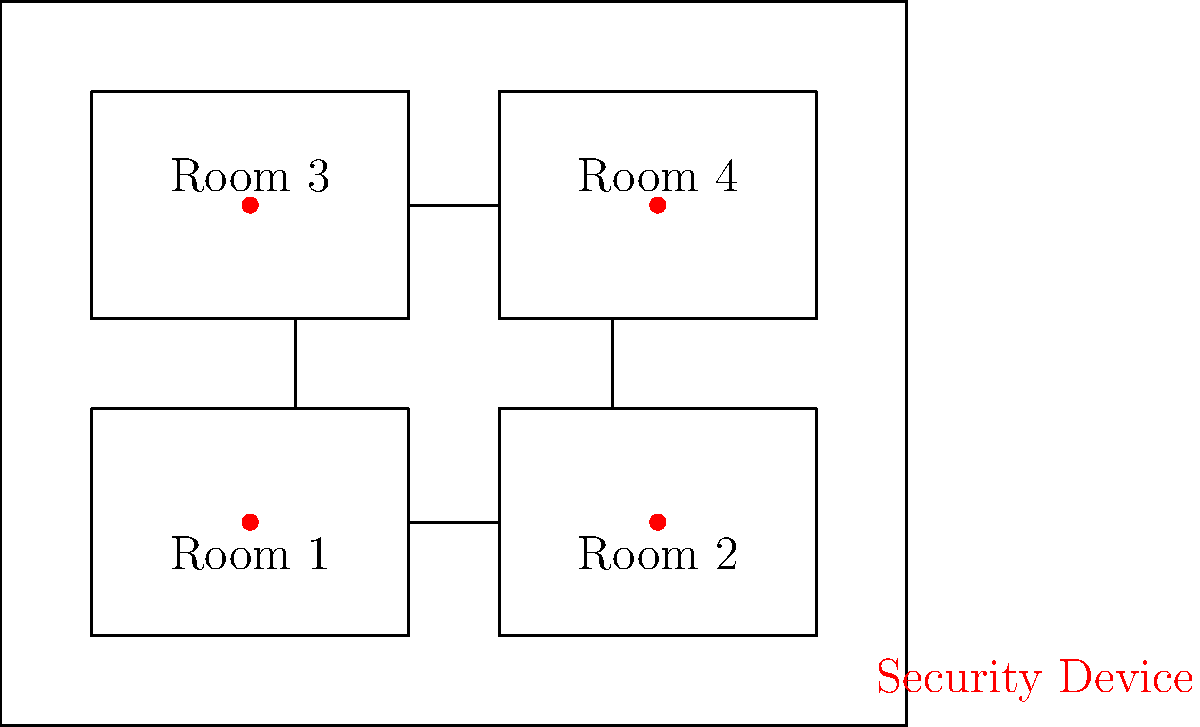Based on the floor plan shown, which integration strategy would be most effective for implementing a comprehensive campus security system that ensures seamless communication between devices and centralized control? To determine the most effective integration strategy for a comprehensive campus security system, we need to consider several factors based on the floor plan:

1. Device distribution: The floor plan shows security devices (red dots) in each room, indicating a need for widespread coverage.

2. Building layout: The building has multiple rooms with interconnecting doors, suggesting a need for coordinated access control.

3. Centralized control: A comprehensive system requires centralized monitoring and control of all devices.

4. Scalability: The solution should be able to accommodate additional devices or buildings in the future.

5. Interoperability: Devices from different manufacturers should be able to communicate seamlessly.

Considering these factors, the most effective integration strategy would be:

Implementing an IP-based security system with a centralized management platform. This approach offers:

a) Network integration: All devices can be connected to the campus network, allowing for easy communication and centralized control.

b) Scalability: Additional devices or buildings can be easily added to the network.

c) Interoperability: IP-based systems often support open standards, allowing integration of devices from various manufacturers.

d) Centralized management: A single platform can monitor and control all devices, streamlining operations.

e) Advanced features: IP-based systems can support features like video analytics, access control integration, and mobile alerts.

This strategy would allow for efficient monitoring of all rooms, coordinated access control between interconnected spaces, and easy expansion to cover more areas of the campus in the future.
Answer: IP-based security system with centralized management platform 